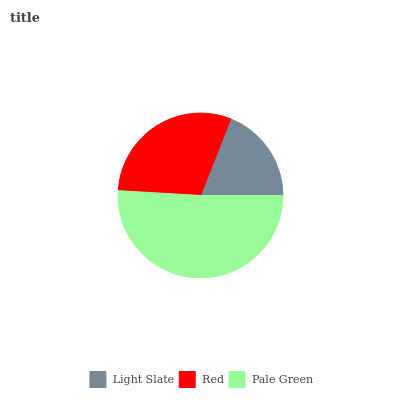Is Light Slate the minimum?
Answer yes or no. Yes. Is Pale Green the maximum?
Answer yes or no. Yes. Is Red the minimum?
Answer yes or no. No. Is Red the maximum?
Answer yes or no. No. Is Red greater than Light Slate?
Answer yes or no. Yes. Is Light Slate less than Red?
Answer yes or no. Yes. Is Light Slate greater than Red?
Answer yes or no. No. Is Red less than Light Slate?
Answer yes or no. No. Is Red the high median?
Answer yes or no. Yes. Is Red the low median?
Answer yes or no. Yes. Is Pale Green the high median?
Answer yes or no. No. Is Pale Green the low median?
Answer yes or no. No. 